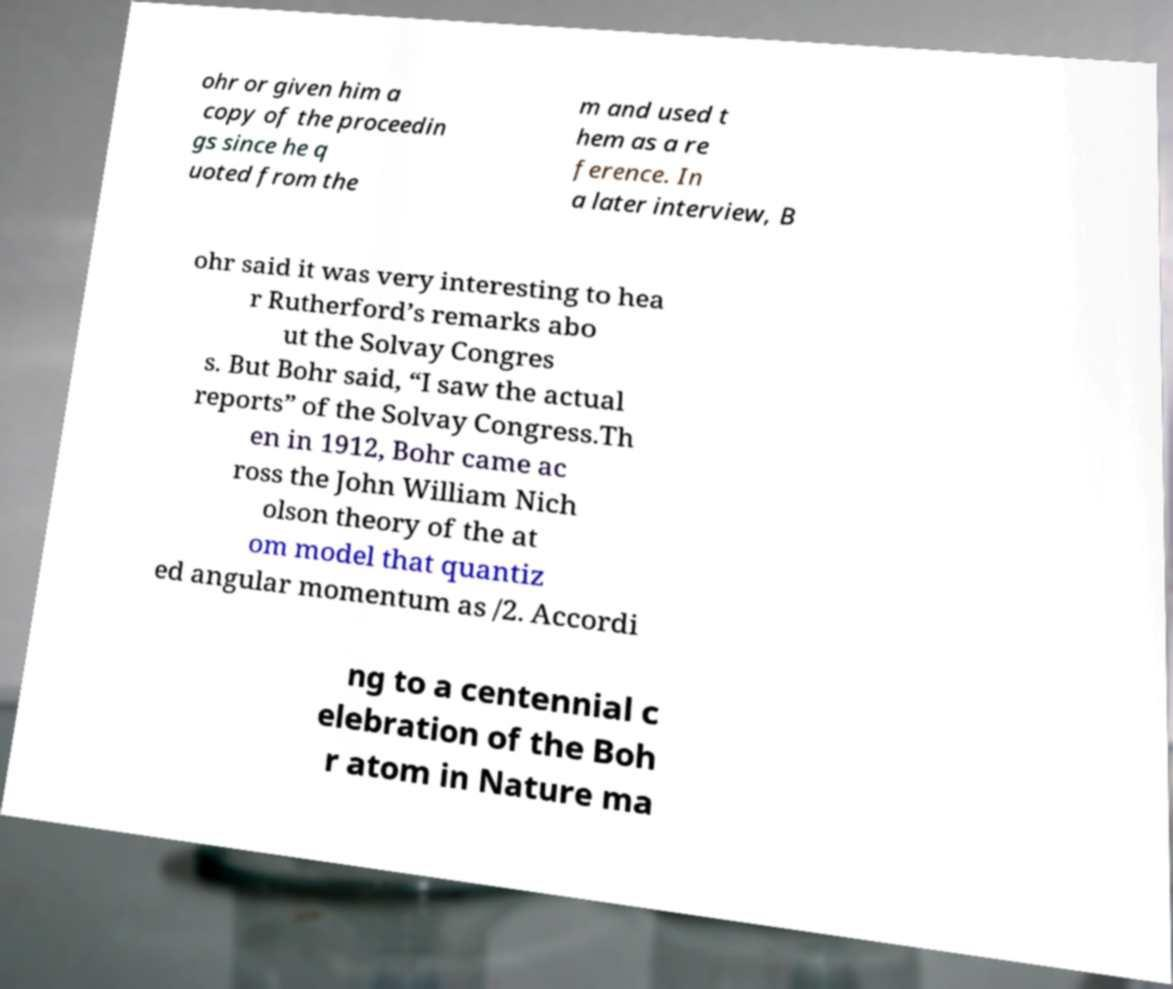Could you extract and type out the text from this image? ohr or given him a copy of the proceedin gs since he q uoted from the m and used t hem as a re ference. In a later interview, B ohr said it was very interesting to hea r Rutherford’s remarks abo ut the Solvay Congres s. But Bohr said, “I saw the actual reports” of the Solvay Congress.Th en in 1912, Bohr came ac ross the John William Nich olson theory of the at om model that quantiz ed angular momentum as /2. Accordi ng to a centennial c elebration of the Boh r atom in Nature ma 